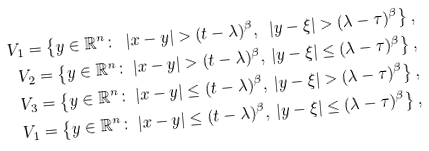Convert formula to latex. <formula><loc_0><loc_0><loc_500><loc_500>V _ { 1 } = \left \{ y \in \mathbb { R } ^ { n } \colon \ | x - y | > ( t - \lambda ) ^ { \beta } , \ | y - \xi | > ( \lambda - \tau ) ^ { \beta } \right \} , \\ V _ { 2 } = \left \{ y \in \mathbb { R } ^ { n } \colon \ | x - y | > ( t - \lambda ) ^ { \beta } , \ | y - \xi | \leq ( \lambda - \tau ) ^ { \beta } \right \} , \\ V _ { 3 } = \left \{ y \in \mathbb { R } ^ { n } \colon \ | x - y | \leq ( t - \lambda ) ^ { \beta } , \ | y - \xi | > ( \lambda - \tau ) ^ { \beta } \right \} , \\ V _ { 1 } = \left \{ y \in \mathbb { R } ^ { n } \colon \ | x - y | \leq ( t - \lambda ) ^ { \beta } , \ | y - \xi | \leq ( \lambda - \tau ) ^ { \beta } \right \} ,</formula> 